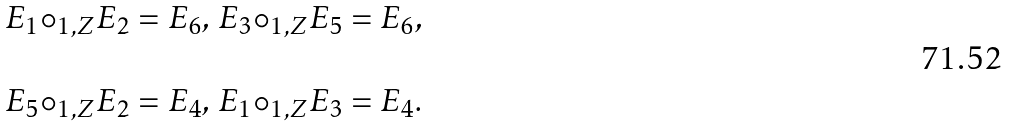<formula> <loc_0><loc_0><loc_500><loc_500>\begin{array} { l } E _ { 1 } { \circ _ { 1 , Z } } E _ { 2 } = E _ { 6 } , \, E _ { 3 } { \circ _ { 1 , Z } } E _ { 5 } = E _ { 6 } , \\ \\ E _ { 5 } { \circ _ { 1 , Z } } E _ { 2 } = E _ { 4 } , \, E _ { 1 } { \circ _ { 1 , Z } } E _ { 3 } = E _ { 4 } . \\ \end{array}</formula> 